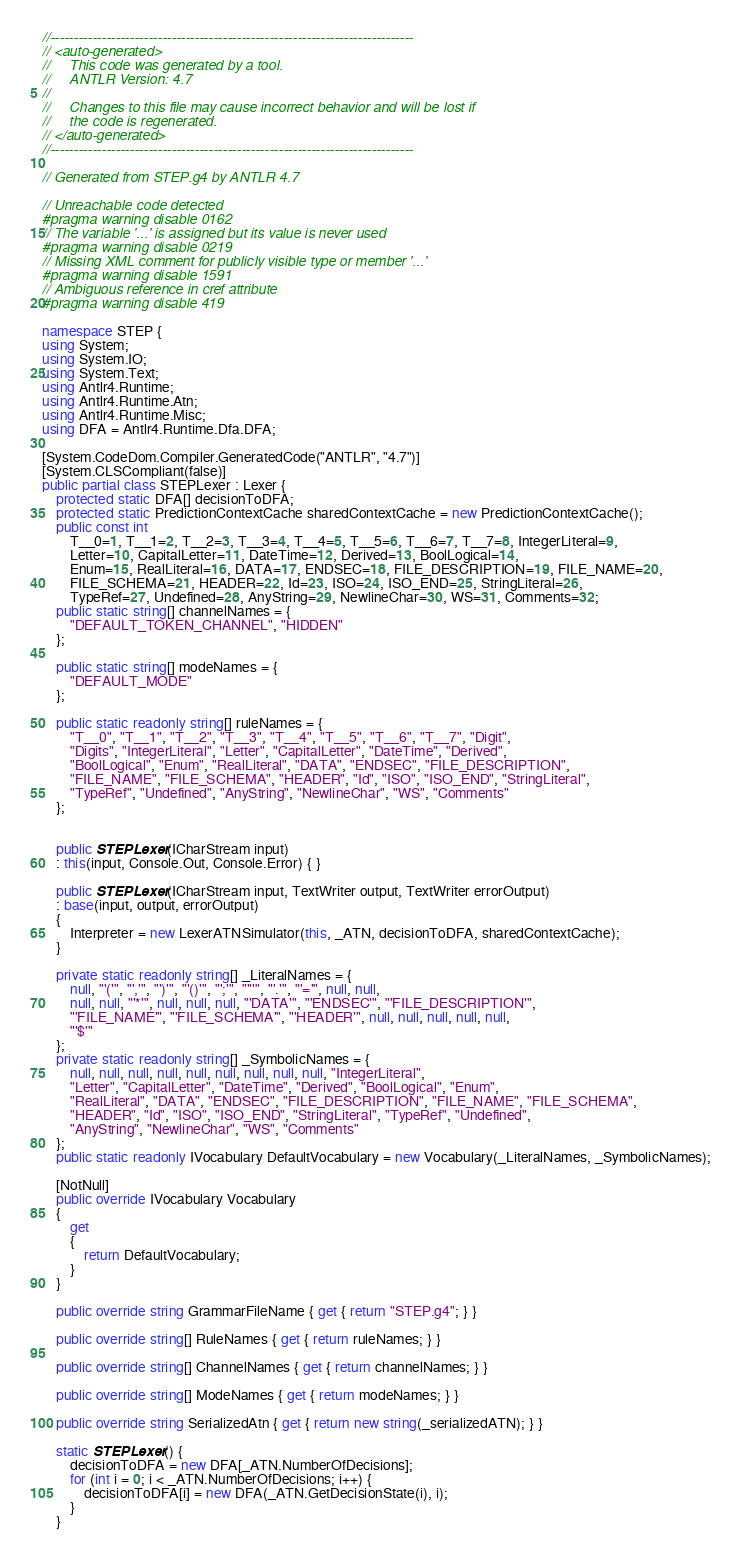<code> <loc_0><loc_0><loc_500><loc_500><_C#_>//------------------------------------------------------------------------------
// <auto-generated>
//     This code was generated by a tool.
//     ANTLR Version: 4.7
//
//     Changes to this file may cause incorrect behavior and will be lost if
//     the code is regenerated.
// </auto-generated>
//------------------------------------------------------------------------------

// Generated from STEP.g4 by ANTLR 4.7

// Unreachable code detected
#pragma warning disable 0162
// The variable '...' is assigned but its value is never used
#pragma warning disable 0219
// Missing XML comment for publicly visible type or member '...'
#pragma warning disable 1591
// Ambiguous reference in cref attribute
#pragma warning disable 419

namespace STEP {
using System;
using System.IO;
using System.Text;
using Antlr4.Runtime;
using Antlr4.Runtime.Atn;
using Antlr4.Runtime.Misc;
using DFA = Antlr4.Runtime.Dfa.DFA;

[System.CodeDom.Compiler.GeneratedCode("ANTLR", "4.7")]
[System.CLSCompliant(false)]
public partial class STEPLexer : Lexer {
	protected static DFA[] decisionToDFA;
	protected static PredictionContextCache sharedContextCache = new PredictionContextCache();
	public const int
		T__0=1, T__1=2, T__2=3, T__3=4, T__4=5, T__5=6, T__6=7, T__7=8, IntegerLiteral=9, 
		Letter=10, CapitalLetter=11, DateTime=12, Derived=13, BoolLogical=14, 
		Enum=15, RealLiteral=16, DATA=17, ENDSEC=18, FILE_DESCRIPTION=19, FILE_NAME=20, 
		FILE_SCHEMA=21, HEADER=22, Id=23, ISO=24, ISO_END=25, StringLiteral=26, 
		TypeRef=27, Undefined=28, AnyString=29, NewlineChar=30, WS=31, Comments=32;
	public static string[] channelNames = {
		"DEFAULT_TOKEN_CHANNEL", "HIDDEN"
	};

	public static string[] modeNames = {
		"DEFAULT_MODE"
	};

	public static readonly string[] ruleNames = {
		"T__0", "T__1", "T__2", "T__3", "T__4", "T__5", "T__6", "T__7", "Digit", 
		"Digits", "IntegerLiteral", "Letter", "CapitalLetter", "DateTime", "Derived", 
		"BoolLogical", "Enum", "RealLiteral", "DATA", "ENDSEC", "FILE_DESCRIPTION", 
		"FILE_NAME", "FILE_SCHEMA", "HEADER", "Id", "ISO", "ISO_END", "StringLiteral", 
		"TypeRef", "Undefined", "AnyString", "NewlineChar", "WS", "Comments"
	};


	public STEPLexer(ICharStream input)
	: this(input, Console.Out, Console.Error) { }

	public STEPLexer(ICharStream input, TextWriter output, TextWriter errorOutput)
	: base(input, output, errorOutput)
	{
		Interpreter = new LexerATNSimulator(this, _ATN, decisionToDFA, sharedContextCache);
	}

	private static readonly string[] _LiteralNames = {
		null, "'('", "','", "')'", "'()'", "';'", "'''", "'.'", "'='", null, null, 
		null, null, "'*'", null, null, null, "'DATA'", "'ENDSEC'", "'FILE_DESCRIPTION'", 
		"'FILE_NAME'", "'FILE_SCHEMA'", "'HEADER'", null, null, null, null, null, 
		"'$'"
	};
	private static readonly string[] _SymbolicNames = {
		null, null, null, null, null, null, null, null, null, "IntegerLiteral", 
		"Letter", "CapitalLetter", "DateTime", "Derived", "BoolLogical", "Enum", 
		"RealLiteral", "DATA", "ENDSEC", "FILE_DESCRIPTION", "FILE_NAME", "FILE_SCHEMA", 
		"HEADER", "Id", "ISO", "ISO_END", "StringLiteral", "TypeRef", "Undefined", 
		"AnyString", "NewlineChar", "WS", "Comments"
	};
	public static readonly IVocabulary DefaultVocabulary = new Vocabulary(_LiteralNames, _SymbolicNames);

	[NotNull]
	public override IVocabulary Vocabulary
	{
		get
		{
			return DefaultVocabulary;
		}
	}

	public override string GrammarFileName { get { return "STEP.g4"; } }

	public override string[] RuleNames { get { return ruleNames; } }

	public override string[] ChannelNames { get { return channelNames; } }

	public override string[] ModeNames { get { return modeNames; } }

	public override string SerializedAtn { get { return new string(_serializedATN); } }

	static STEPLexer() {
		decisionToDFA = new DFA[_ATN.NumberOfDecisions];
		for (int i = 0; i < _ATN.NumberOfDecisions; i++) {
			decisionToDFA[i] = new DFA(_ATN.GetDecisionState(i), i);
		}
	}</code> 